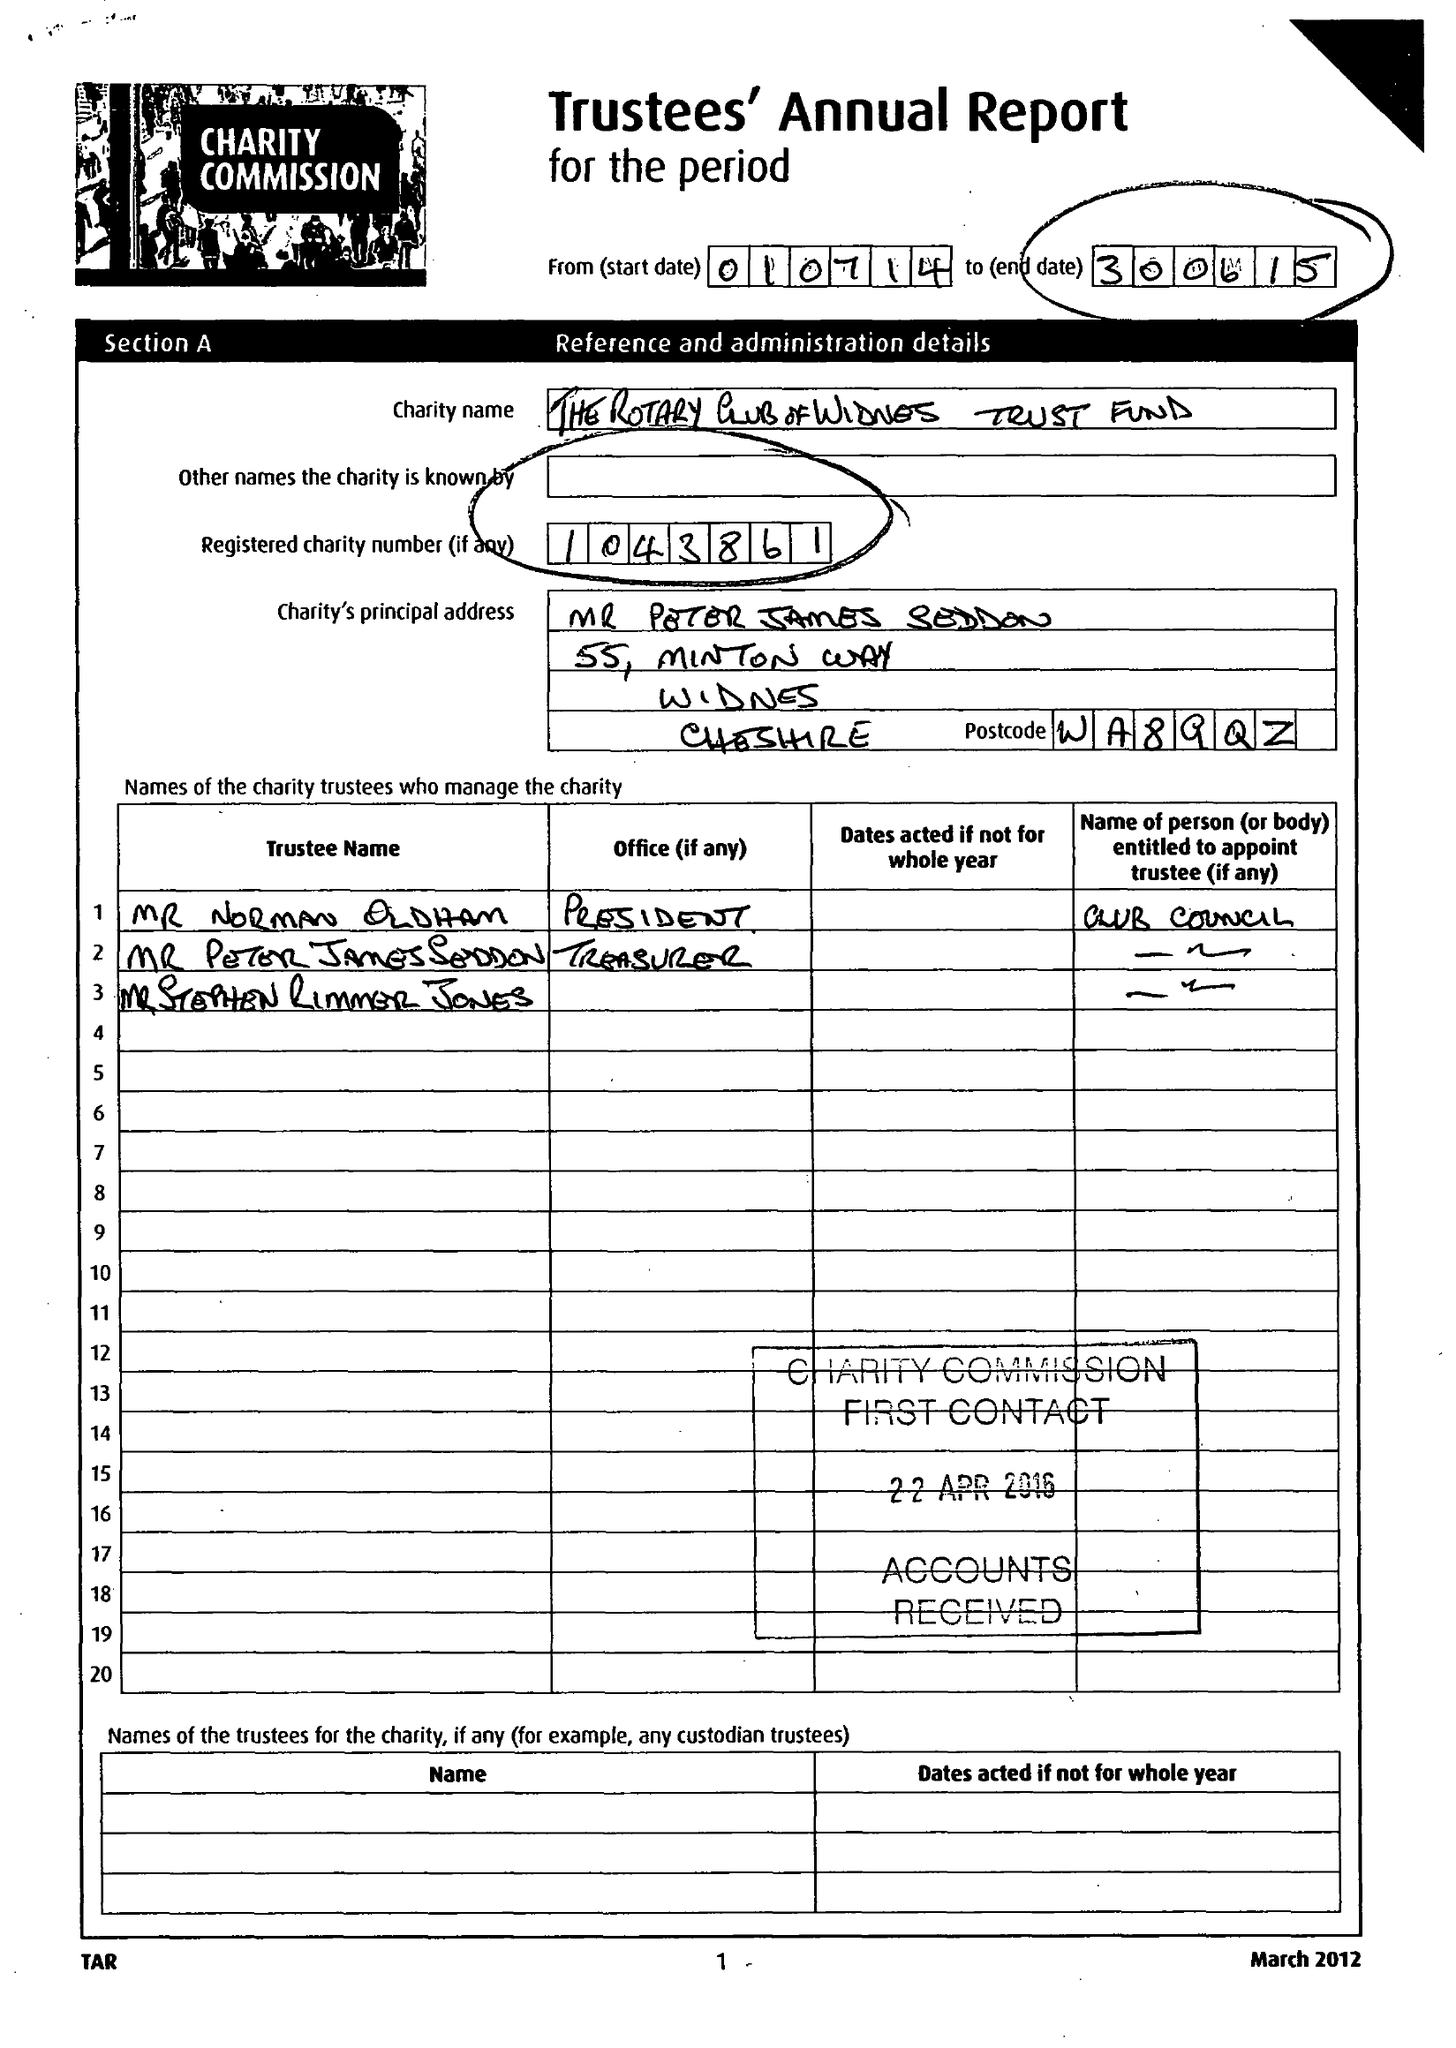What is the value for the charity_number?
Answer the question using a single word or phrase. 1043861 